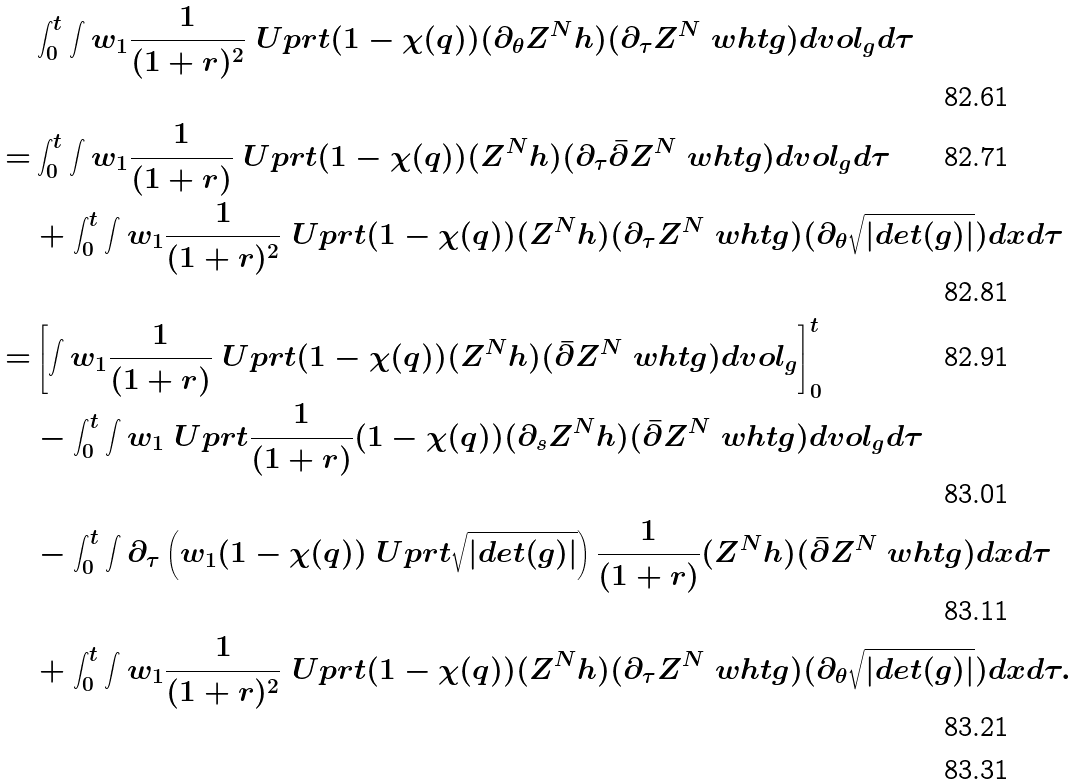<formula> <loc_0><loc_0><loc_500><loc_500>& \int _ { 0 } ^ { t } \int w _ { 1 } \frac { 1 } { ( 1 + r ) ^ { 2 } } \ U p r t ( 1 - \chi ( q ) ) ( \partial _ { \theta } Z ^ { N } h ) ( \partial _ { \tau } Z ^ { N } \ w h t g ) d v o l _ { g } d \tau \\ = & \int _ { 0 } ^ { t } \int w _ { 1 } \frac { 1 } { ( 1 + r ) } \ U p r t ( 1 - \chi ( q ) ) ( Z ^ { N } h ) ( \partial _ { \tau } \bar { \partial } Z ^ { N } \ w h t g ) d v o l _ { g } d \tau \\ & + \int _ { 0 } ^ { t } \int w _ { 1 } \frac { 1 } { ( 1 + r ) ^ { 2 } } \ U p r t ( 1 - \chi ( q ) ) ( Z ^ { N } h ) ( \partial _ { \tau } Z ^ { N } \ w h t g ) ( \partial _ { \theta } \sqrt { | d e t ( g ) | } ) d x d \tau \\ = & \left [ \int w _ { 1 } \frac { 1 } { ( 1 + r ) } \ U p r t ( 1 - \chi ( q ) ) ( Z ^ { N } h ) ( \bar { \partial } Z ^ { N } \ w h t g ) d v o l _ { g } \right ] _ { 0 } ^ { t } \\ & - \int _ { 0 } ^ { t } \int w _ { 1 } \ U p r t \frac { 1 } { ( 1 + r ) } ( 1 - \chi ( q ) ) ( \partial _ { s } Z ^ { N } h ) ( \bar { \partial } Z ^ { N } \ w h t g ) d v o l _ { g } d \tau \\ & - \int _ { 0 } ^ { t } \int \partial _ { \tau } \left ( w _ { 1 } ( 1 - \chi ( q ) ) \ U p r t \sqrt { | d e t ( g ) | } \right ) \frac { 1 } { ( 1 + r ) } ( Z ^ { N } h ) ( \bar { \partial } Z ^ { N } \ w h t g ) d x d \tau \\ & + \int _ { 0 } ^ { t } \int w _ { 1 } \frac { 1 } { ( 1 + r ) ^ { 2 } } \ U p r t ( 1 - \chi ( q ) ) ( Z ^ { N } h ) ( \partial _ { \tau } Z ^ { N } \ w h t g ) ( \partial _ { \theta } \sqrt { | d e t ( g ) | } ) d x d \tau . \\</formula> 